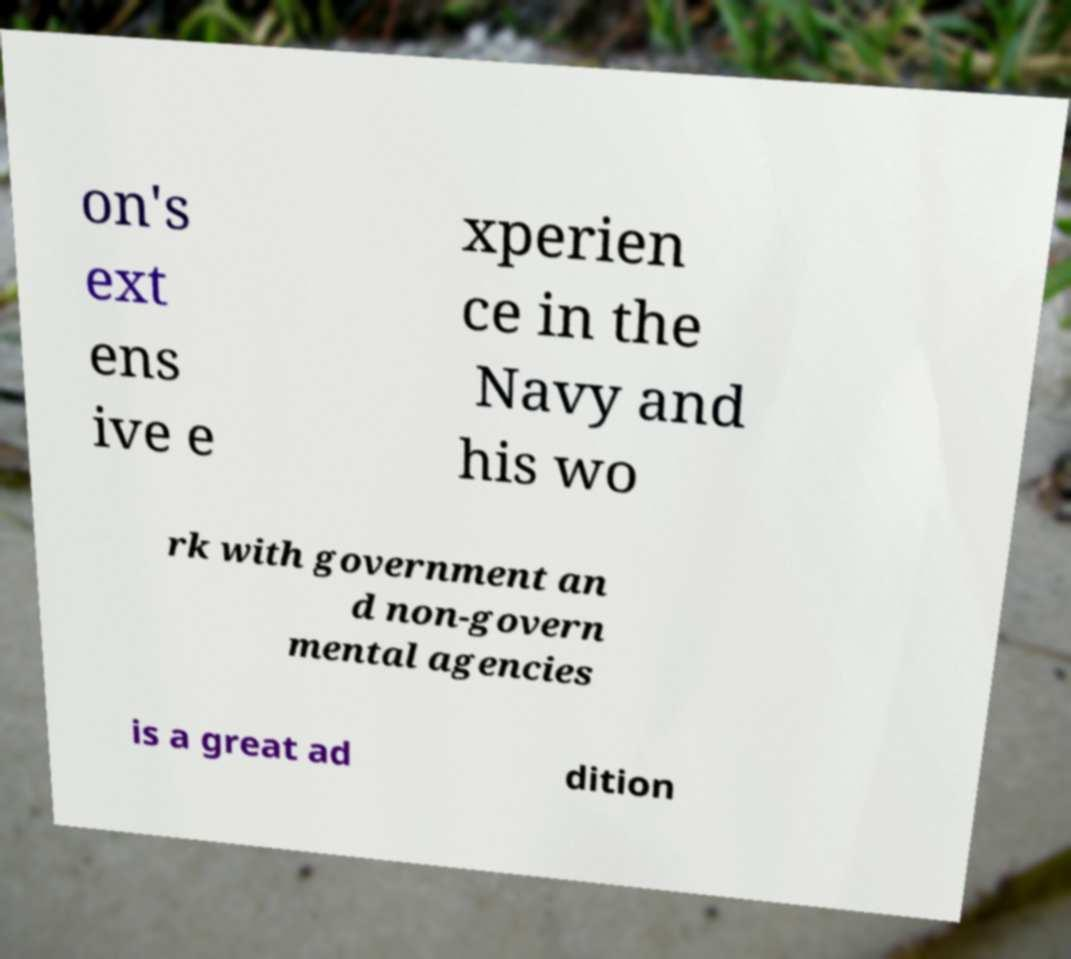Could you assist in decoding the text presented in this image and type it out clearly? on's ext ens ive e xperien ce in the Navy and his wo rk with government an d non-govern mental agencies is a great ad dition 